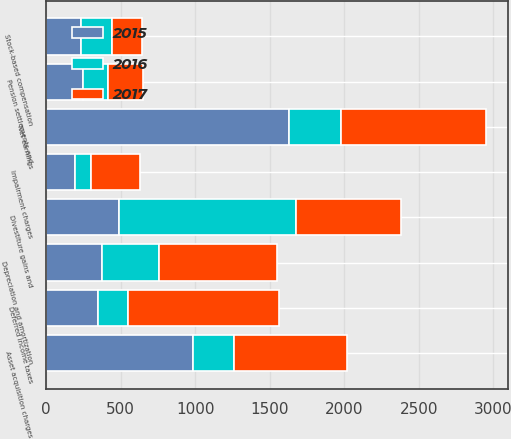Convert chart. <chart><loc_0><loc_0><loc_500><loc_500><stacked_bar_chart><ecel><fcel>Net earnings<fcel>Depreciation and amortization<fcel>Deferred income taxes<fcel>Stock-based compensation<fcel>Impairment charges<fcel>Pension settlements and<fcel>Divestiture gains and<fcel>Asset acquisition charges<nl><fcel>2017<fcel>975<fcel>789<fcel>1010<fcel>199<fcel>332<fcel>236<fcel>706<fcel>760<nl><fcel>2016<fcel>347<fcel>382<fcel>204<fcel>205<fcel>108<fcel>169<fcel>1187<fcel>274<nl><fcel>2015<fcel>1631<fcel>376<fcel>347<fcel>235<fcel>192<fcel>245<fcel>490<fcel>983<nl></chart> 